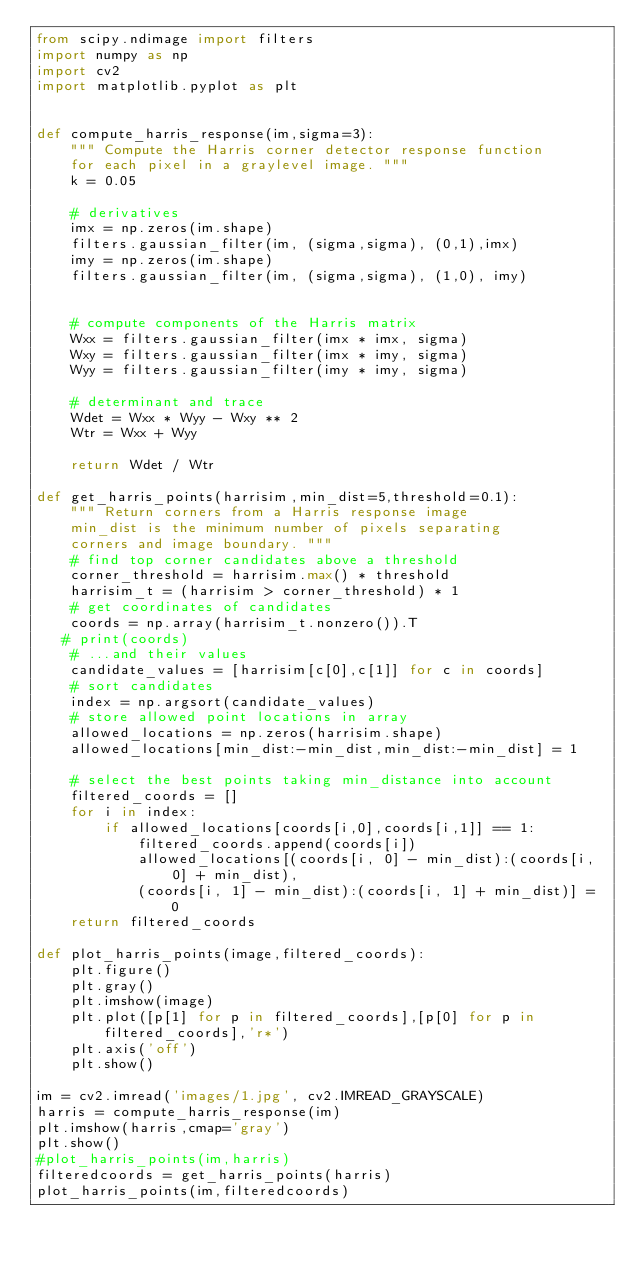<code> <loc_0><loc_0><loc_500><loc_500><_Python_>from scipy.ndimage import filters
import numpy as np
import cv2
import matplotlib.pyplot as plt


def compute_harris_response(im,sigma=3):
    """ Compute the Harris corner detector response function
    for each pixel in a graylevel image. """
    k = 0.05

    # derivatives
    imx = np.zeros(im.shape)
    filters.gaussian_filter(im, (sigma,sigma), (0,1),imx)
    imy = np.zeros(im.shape)
    filters.gaussian_filter(im, (sigma,sigma), (1,0), imy)


    # compute components of the Harris matrix
    Wxx = filters.gaussian_filter(imx * imx, sigma)
    Wxy = filters.gaussian_filter(imx * imy, sigma)
    Wyy = filters.gaussian_filter(imy * imy, sigma)

    # determinant and trace
    Wdet = Wxx * Wyy - Wxy ** 2
    Wtr = Wxx + Wyy

    return Wdet / Wtr

def get_harris_points(harrisim,min_dist=5,threshold=0.1):
    """ Return corners from a Harris response image
    min_dist is the minimum number of pixels separating
    corners and image boundary. """
    # find top corner candidates above a threshold
    corner_threshold = harrisim.max() * threshold
    harrisim_t = (harrisim > corner_threshold) * 1
    # get coordinates of candidates
    coords = np.array(harrisim_t.nonzero()).T
   # print(coords)
    # ...and their values
    candidate_values = [harrisim[c[0],c[1]] for c in coords]
    # sort candidates
    index = np.argsort(candidate_values)
    # store allowed point locations in array
    allowed_locations = np.zeros(harrisim.shape)
    allowed_locations[min_dist:-min_dist,min_dist:-min_dist] = 1

    # select the best points taking min_distance into account
    filtered_coords = []
    for i in index:
        if allowed_locations[coords[i,0],coords[i,1]] == 1:
            filtered_coords.append(coords[i])
            allowed_locations[(coords[i, 0] - min_dist):(coords[i, 0] + min_dist),
            (coords[i, 1] - min_dist):(coords[i, 1] + min_dist)] = 0
    return filtered_coords

def plot_harris_points(image,filtered_coords):
    plt.figure()
    plt.gray()
    plt.imshow(image)
    plt.plot([p[1] for p in filtered_coords],[p[0] for p in filtered_coords],'r*')
    plt.axis('off')
    plt.show()

im = cv2.imread('images/1.jpg', cv2.IMREAD_GRAYSCALE)
harris = compute_harris_response(im)
plt.imshow(harris,cmap='gray')
plt.show()
#plot_harris_points(im,harris)
filteredcoords = get_harris_points(harris)
plot_harris_points(im,filteredcoords)</code> 